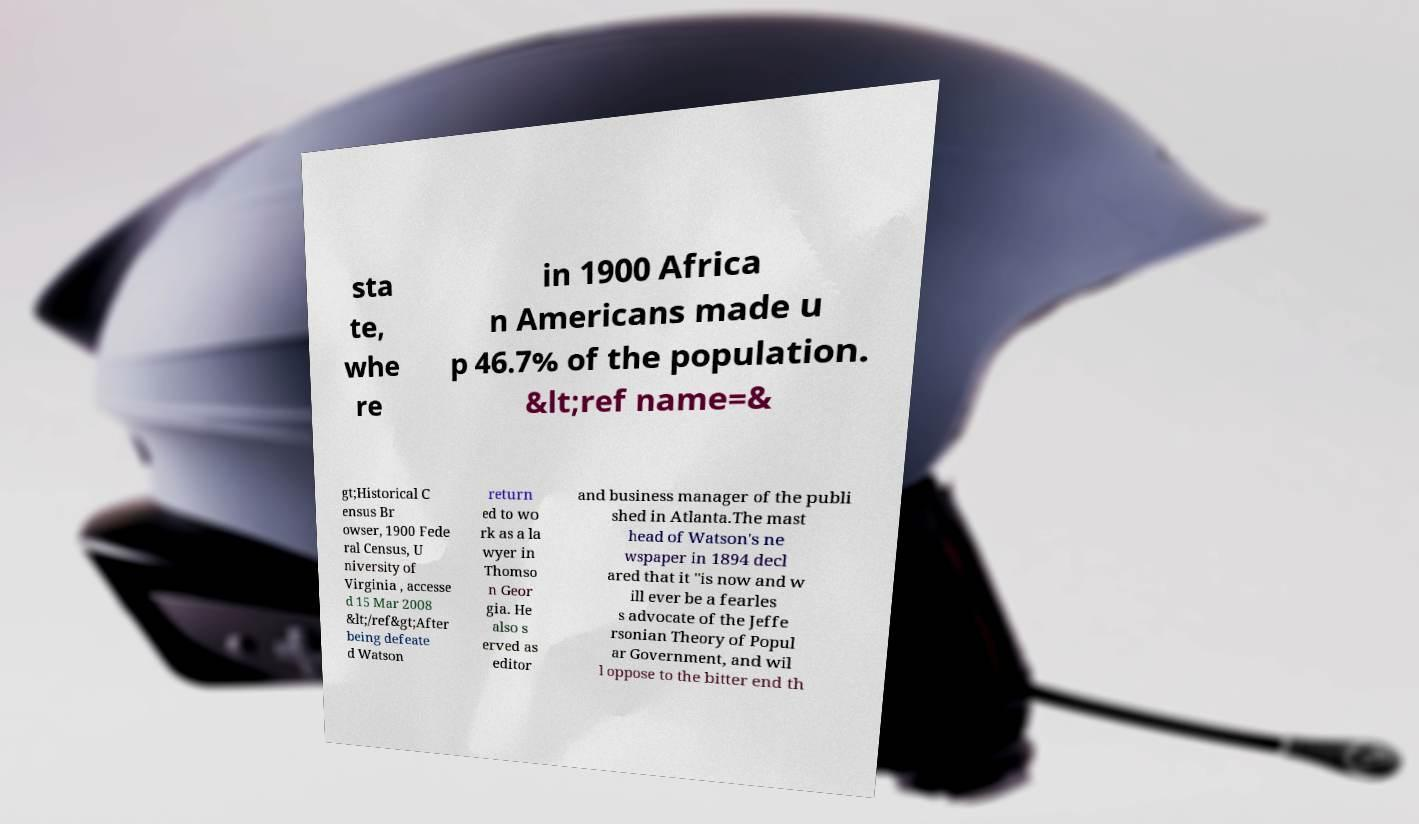Could you assist in decoding the text presented in this image and type it out clearly? sta te, whe re in 1900 Africa n Americans made u p 46.7% of the population. &lt;ref name=& gt;Historical C ensus Br owser, 1900 Fede ral Census, U niversity of Virginia , accesse d 15 Mar 2008 &lt;/ref&gt;After being defeate d Watson return ed to wo rk as a la wyer in Thomso n Geor gia. He also s erved as editor and business manager of the publi shed in Atlanta.The mast head of Watson's ne wspaper in 1894 decl ared that it "is now and w ill ever be a fearles s advocate of the Jeffe rsonian Theory of Popul ar Government, and wil l oppose to the bitter end th 